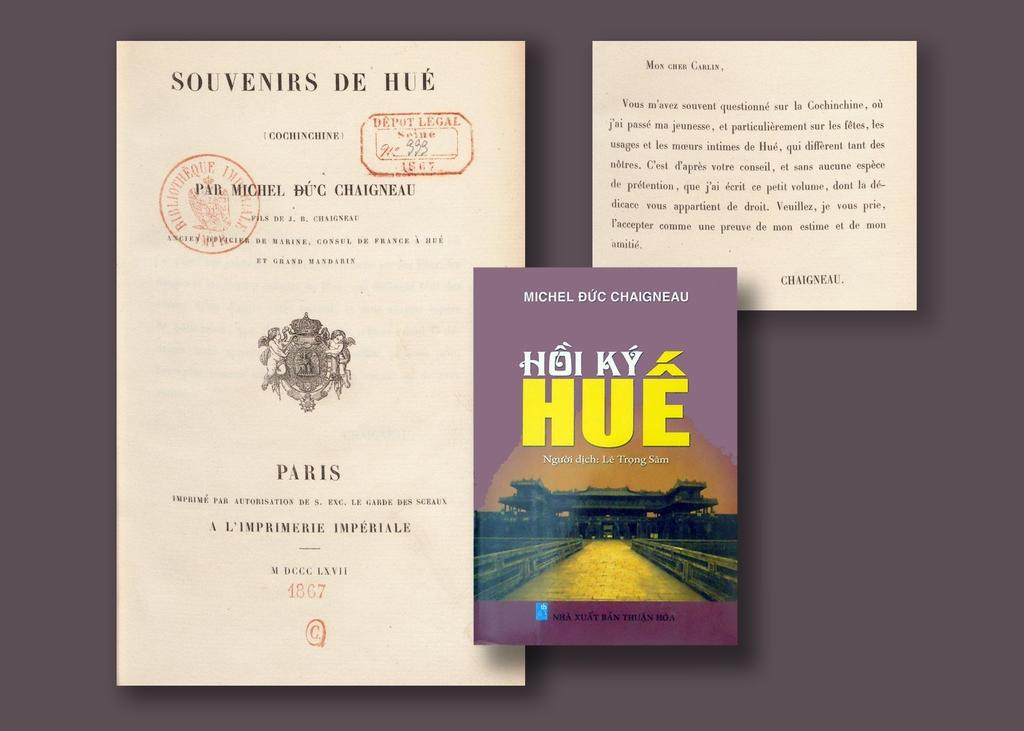<image>
Describe the image concisely. A book with the word Hue on it sits between two different sized pieces of paper. 